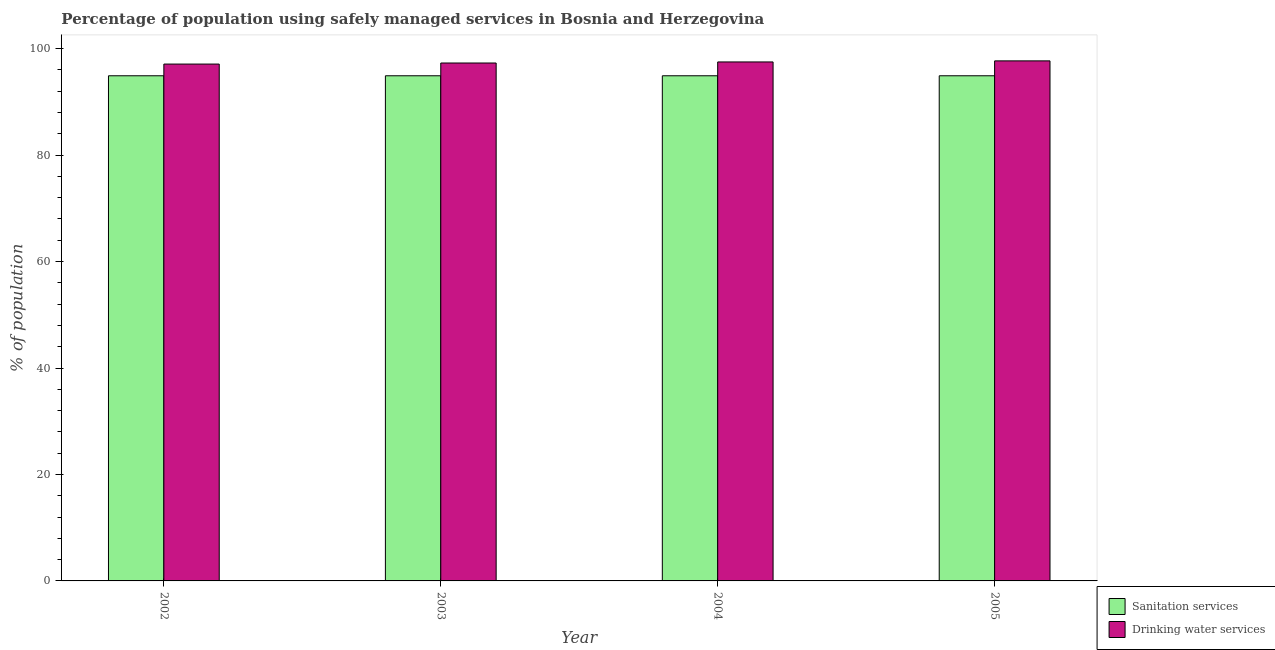How many groups of bars are there?
Provide a succinct answer. 4. Are the number of bars per tick equal to the number of legend labels?
Give a very brief answer. Yes. Are the number of bars on each tick of the X-axis equal?
Your answer should be compact. Yes. How many bars are there on the 1st tick from the left?
Provide a short and direct response. 2. How many bars are there on the 3rd tick from the right?
Give a very brief answer. 2. In how many cases, is the number of bars for a given year not equal to the number of legend labels?
Offer a terse response. 0. What is the percentage of population who used drinking water services in 2003?
Give a very brief answer. 97.3. Across all years, what is the maximum percentage of population who used sanitation services?
Give a very brief answer. 94.9. Across all years, what is the minimum percentage of population who used drinking water services?
Make the answer very short. 97.1. What is the total percentage of population who used sanitation services in the graph?
Provide a succinct answer. 379.6. What is the difference between the percentage of population who used sanitation services in 2002 and that in 2004?
Ensure brevity in your answer.  0. What is the difference between the percentage of population who used sanitation services in 2003 and the percentage of population who used drinking water services in 2002?
Keep it short and to the point. 0. What is the average percentage of population who used sanitation services per year?
Make the answer very short. 94.9. In how many years, is the percentage of population who used drinking water services greater than 28 %?
Your answer should be very brief. 4. What is the ratio of the percentage of population who used sanitation services in 2002 to that in 2003?
Your response must be concise. 1. What is the difference between the highest and the second highest percentage of population who used drinking water services?
Give a very brief answer. 0.2. In how many years, is the percentage of population who used sanitation services greater than the average percentage of population who used sanitation services taken over all years?
Offer a very short reply. 0. What does the 2nd bar from the left in 2004 represents?
Your answer should be very brief. Drinking water services. What does the 2nd bar from the right in 2005 represents?
Your answer should be compact. Sanitation services. How many bars are there?
Give a very brief answer. 8. Are all the bars in the graph horizontal?
Your answer should be compact. No. How many years are there in the graph?
Provide a succinct answer. 4. Does the graph contain grids?
Your answer should be compact. No. Where does the legend appear in the graph?
Ensure brevity in your answer.  Bottom right. How are the legend labels stacked?
Ensure brevity in your answer.  Vertical. What is the title of the graph?
Ensure brevity in your answer.  Percentage of population using safely managed services in Bosnia and Herzegovina. What is the label or title of the X-axis?
Provide a succinct answer. Year. What is the label or title of the Y-axis?
Provide a succinct answer. % of population. What is the % of population in Sanitation services in 2002?
Provide a succinct answer. 94.9. What is the % of population in Drinking water services in 2002?
Keep it short and to the point. 97.1. What is the % of population in Sanitation services in 2003?
Make the answer very short. 94.9. What is the % of population in Drinking water services in 2003?
Offer a terse response. 97.3. What is the % of population in Sanitation services in 2004?
Keep it short and to the point. 94.9. What is the % of population in Drinking water services in 2004?
Your response must be concise. 97.5. What is the % of population in Sanitation services in 2005?
Ensure brevity in your answer.  94.9. What is the % of population of Drinking water services in 2005?
Offer a terse response. 97.7. Across all years, what is the maximum % of population of Sanitation services?
Your answer should be compact. 94.9. Across all years, what is the maximum % of population in Drinking water services?
Your response must be concise. 97.7. Across all years, what is the minimum % of population of Sanitation services?
Offer a very short reply. 94.9. Across all years, what is the minimum % of population of Drinking water services?
Make the answer very short. 97.1. What is the total % of population in Sanitation services in the graph?
Make the answer very short. 379.6. What is the total % of population of Drinking water services in the graph?
Offer a terse response. 389.6. What is the difference between the % of population of Sanitation services in 2002 and that in 2003?
Give a very brief answer. 0. What is the difference between the % of population in Sanitation services in 2002 and that in 2004?
Your answer should be compact. 0. What is the difference between the % of population of Sanitation services in 2002 and that in 2005?
Provide a succinct answer. 0. What is the difference between the % of population in Drinking water services in 2003 and that in 2004?
Provide a succinct answer. -0.2. What is the difference between the % of population of Sanitation services in 2003 and that in 2005?
Provide a succinct answer. 0. What is the difference between the % of population of Drinking water services in 2003 and that in 2005?
Keep it short and to the point. -0.4. What is the difference between the % of population in Sanitation services in 2004 and that in 2005?
Give a very brief answer. 0. What is the difference between the % of population in Sanitation services in 2002 and the % of population in Drinking water services in 2004?
Make the answer very short. -2.6. What is the difference between the % of population in Sanitation services in 2003 and the % of population in Drinking water services in 2004?
Your answer should be very brief. -2.6. What is the difference between the % of population of Sanitation services in 2003 and the % of population of Drinking water services in 2005?
Make the answer very short. -2.8. What is the average % of population in Sanitation services per year?
Your answer should be compact. 94.9. What is the average % of population of Drinking water services per year?
Ensure brevity in your answer.  97.4. In the year 2004, what is the difference between the % of population in Sanitation services and % of population in Drinking water services?
Your answer should be compact. -2.6. What is the ratio of the % of population of Sanitation services in 2002 to that in 2003?
Keep it short and to the point. 1. What is the ratio of the % of population in Drinking water services in 2002 to that in 2004?
Provide a succinct answer. 1. What is the ratio of the % of population of Sanitation services in 2002 to that in 2005?
Your answer should be very brief. 1. What is the ratio of the % of population in Drinking water services in 2002 to that in 2005?
Offer a very short reply. 0.99. What is the ratio of the % of population in Sanitation services in 2003 to that in 2004?
Provide a succinct answer. 1. What is the ratio of the % of population in Drinking water services in 2003 to that in 2004?
Offer a terse response. 1. What is the ratio of the % of population of Drinking water services in 2003 to that in 2005?
Your answer should be compact. 1. What is the ratio of the % of population of Sanitation services in 2004 to that in 2005?
Keep it short and to the point. 1. What is the ratio of the % of population in Drinking water services in 2004 to that in 2005?
Ensure brevity in your answer.  1. What is the difference between the highest and the second highest % of population in Sanitation services?
Give a very brief answer. 0. What is the difference between the highest and the second highest % of population in Drinking water services?
Give a very brief answer. 0.2. What is the difference between the highest and the lowest % of population of Drinking water services?
Your answer should be very brief. 0.6. 